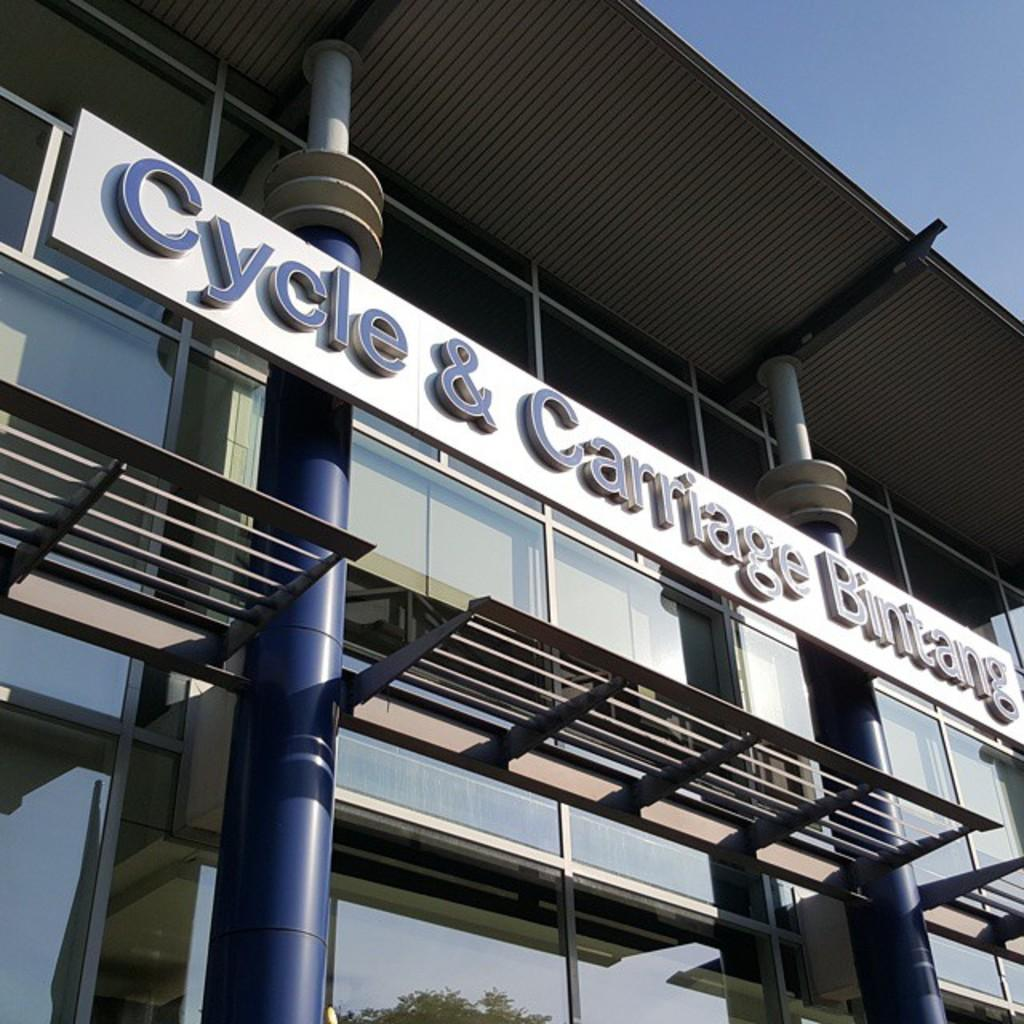Where was the image taken? The image is taken outdoors. What can be seen at the top of the image? The sky is visible at the top of the image. What is the main structure in the middle of the image? There is a building in the middle of the image. How many pillars are present in the image? There are two pillars in the image. What is written or displayed on the board in the image? There is a board with text in the image. What is the reaction of the office when the building catches fire in the image? There is no office or fire present in the image; it only features a building, two pillars, and a board with text. 